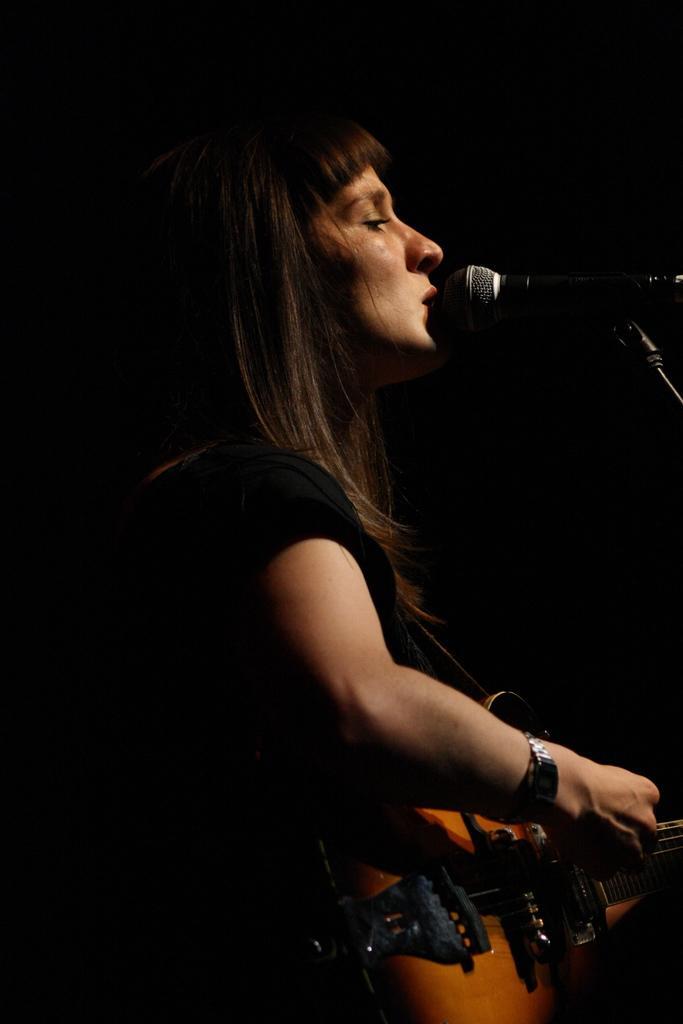In one or two sentences, can you explain what this image depicts? In this picture, we see woman in black t-shirt is holding guitar in her hands and playing it. In front of her, we see microphone and she is singing on microphone. 